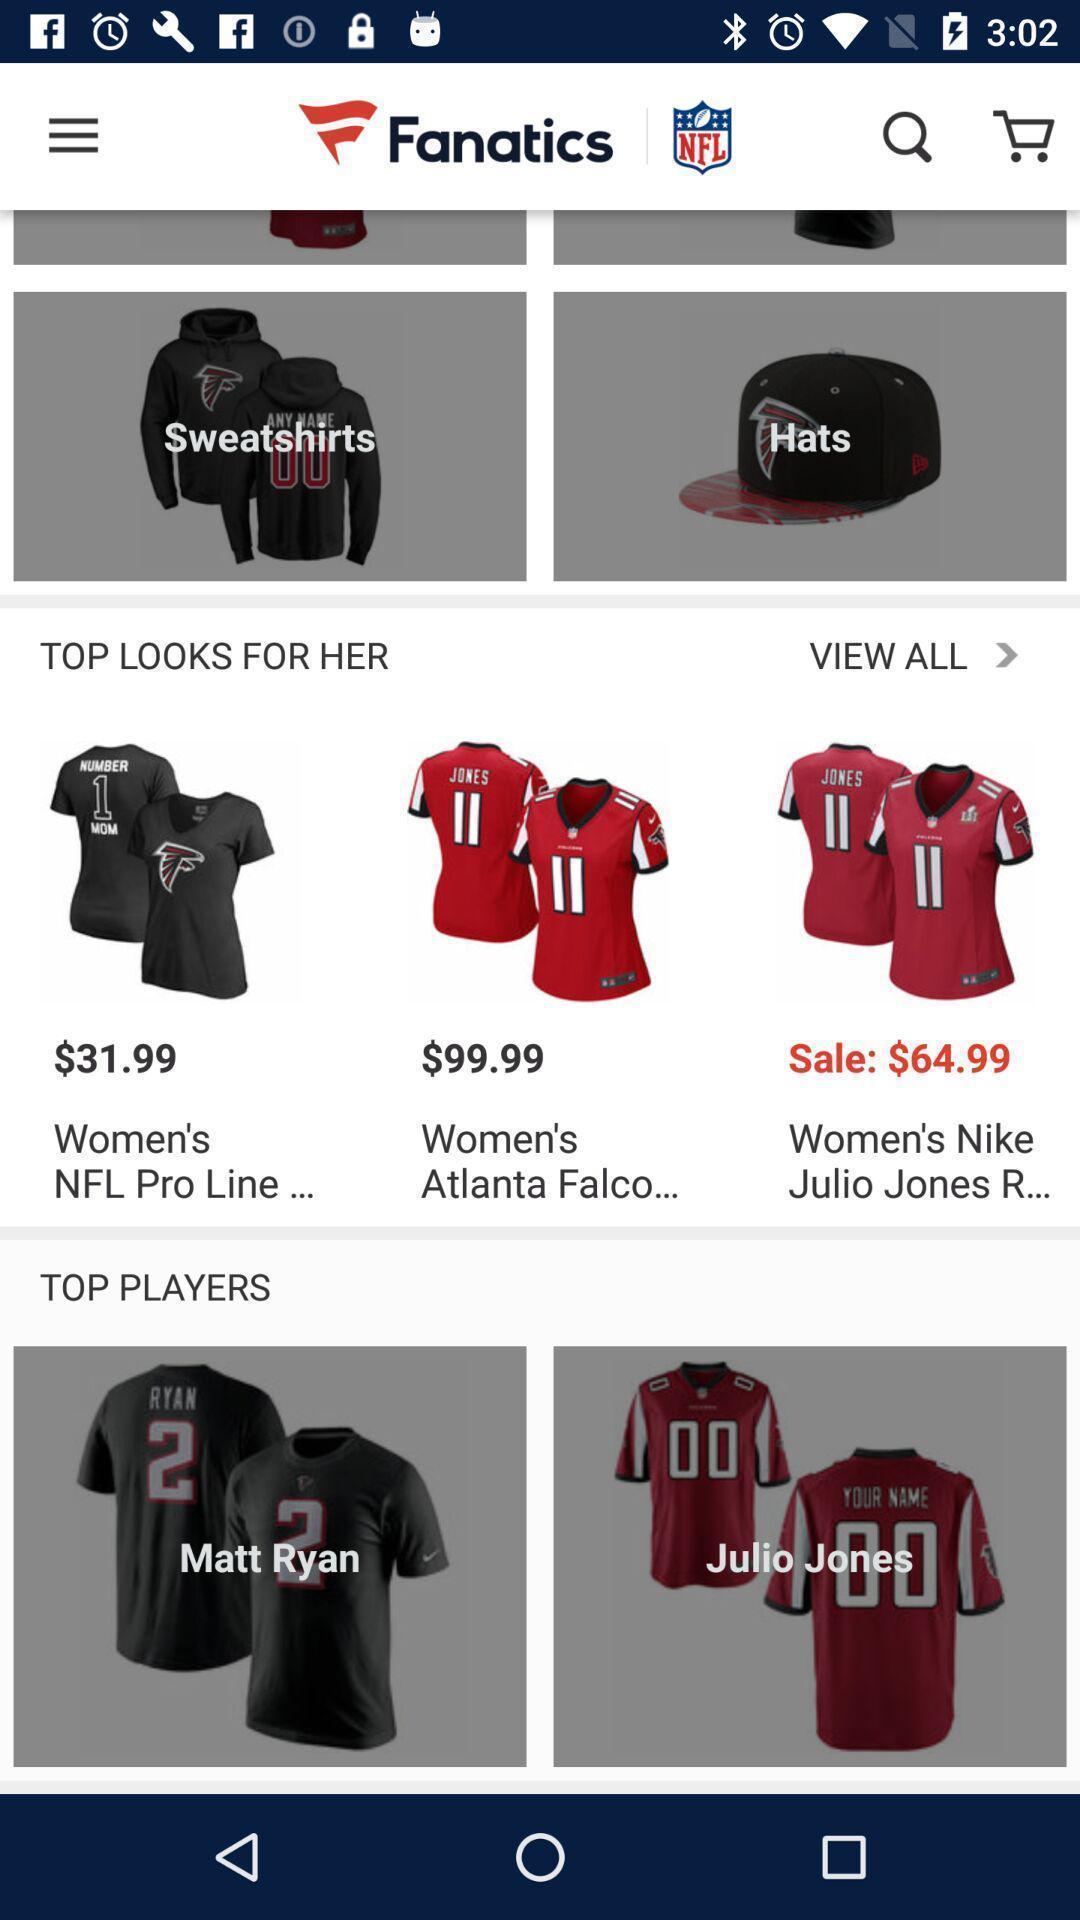What is the overall content of this screenshot? Page showing apparel section in a sports based shopping app. 